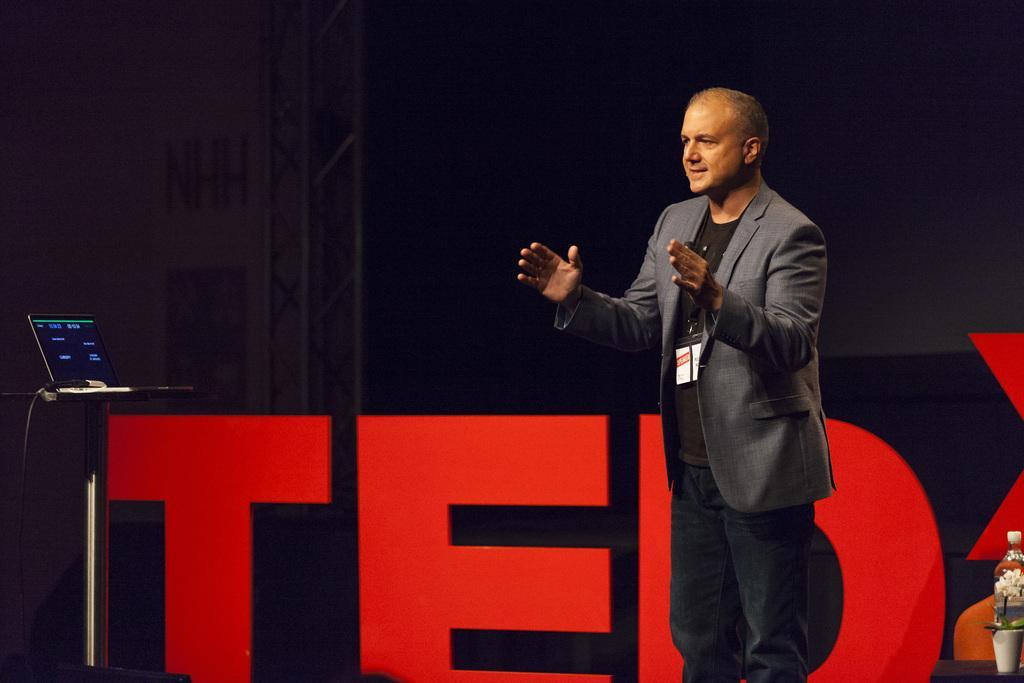Describe this image in one or two sentences. In this picture there is a person standing on the stage and he is talking. On the right side of the image there is a bottle and flower vase on the table. At the back there is a hoarding. On the left side of the image there is a laptop on the table. 